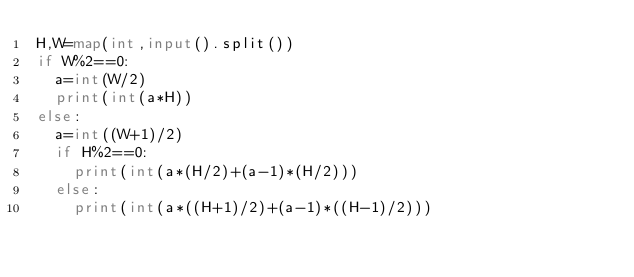<code> <loc_0><loc_0><loc_500><loc_500><_Python_>H,W=map(int,input().split())
if W%2==0:
	a=int(W/2)
	print(int(a*H))
else:
	a=int((W+1)/2)
	if H%2==0:
		print(int(a*(H/2)+(a-1)*(H/2)))
	else:
		print(int(a*((H+1)/2)+(a-1)*((H-1)/2)))</code> 